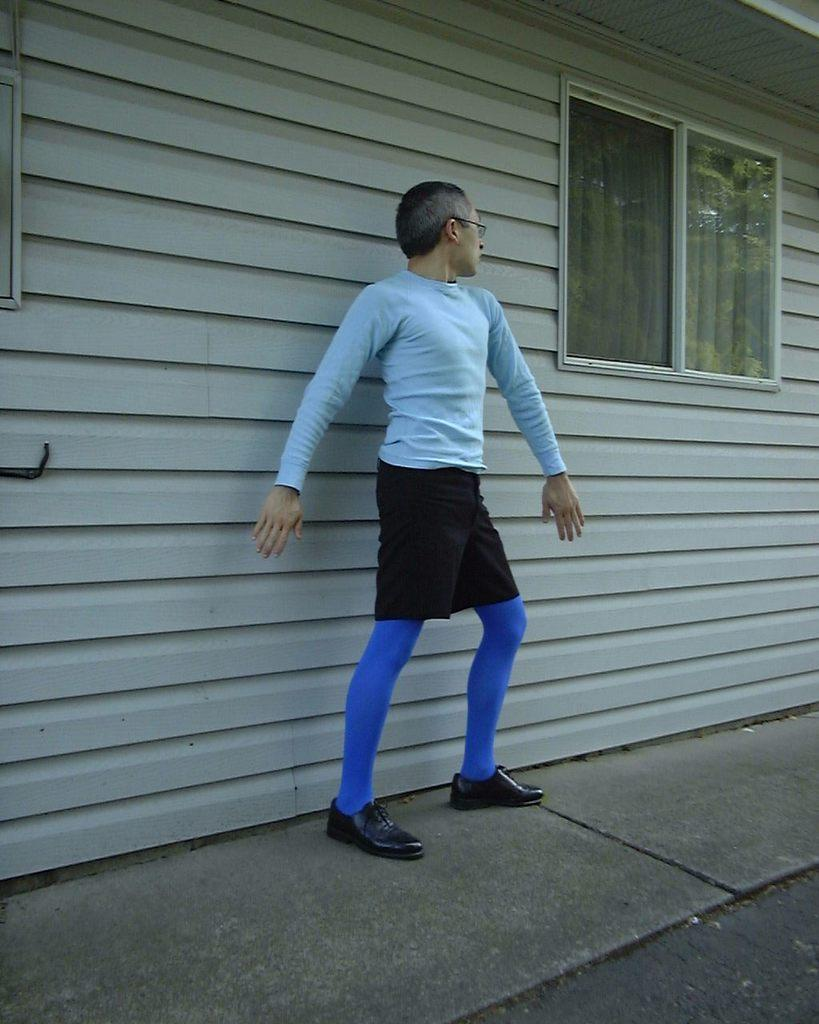Who is the main subject in the image? There is a man in the middle of the image. What is the man wearing on his upper body? The man is wearing a t-shirt. What is the man wearing on his lower body? The man is wearing trousers. What is the man wearing on his feet? The man is wearing shoes. What is visible at the bottom of the image? There is a floor visible at the bottom of the image. What can be seen in the background of the image? There is a house, a window, glass, a curtain, and a wall visible in the background of the image. What type of cloth is being used to build the bridge in the image? There is no bridge present in the image, so it is not possible to determine what type of cloth might be used in its construction. 